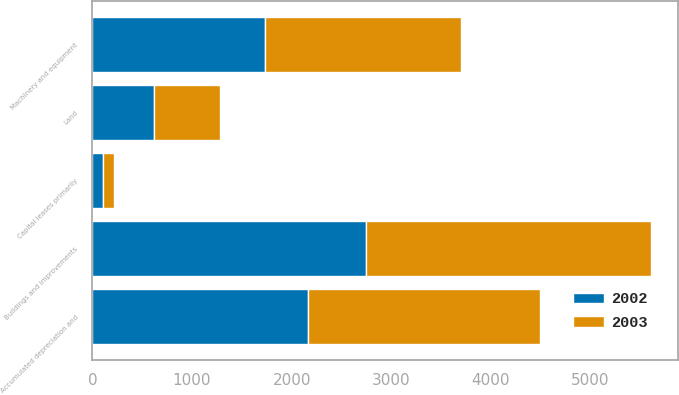<chart> <loc_0><loc_0><loc_500><loc_500><stacked_bar_chart><ecel><fcel>Land<fcel>Buildings and improvements<fcel>Capital leases primarily<fcel>Machinery and equipment<fcel>Accumulated depreciation and<nl><fcel>2003<fcel>662<fcel>2861<fcel>119<fcel>1964<fcel>2326<nl><fcel>2002<fcel>621<fcel>2742<fcel>102<fcel>1736<fcel>2164<nl></chart> 